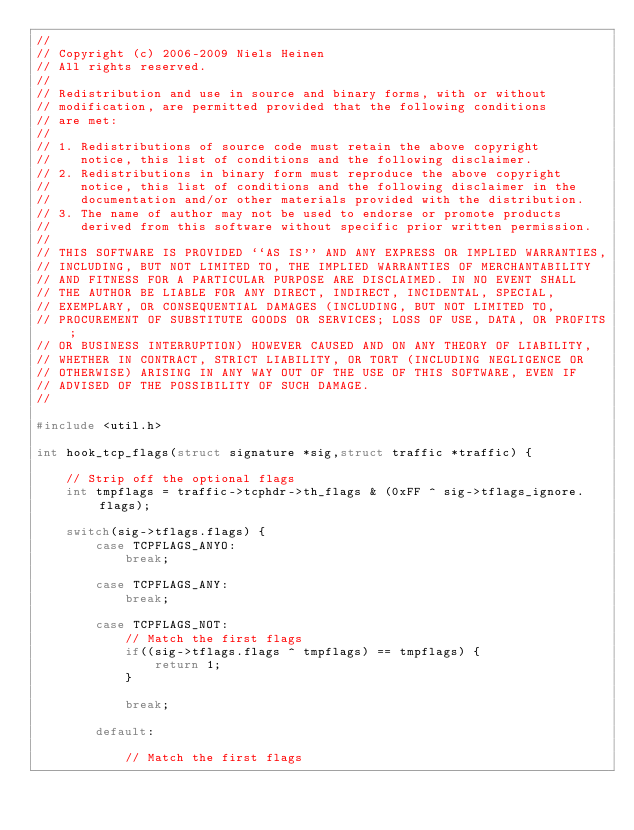Convert code to text. <code><loc_0><loc_0><loc_500><loc_500><_C_>//
// Copyright (c) 2006-2009 Niels Heinen
// All rights reserved.
//
// Redistribution and use in source and binary forms, with or without
// modification, are permitted provided that the following conditions
// are met:
//
// 1. Redistributions of source code must retain the above copyright
//    notice, this list of conditions and the following disclaimer.
// 2. Redistributions in binary form must reproduce the above copyright
//    notice, this list of conditions and the following disclaimer in the
//    documentation and/or other materials provided with the distribution.
// 3. The name of author may not be used to endorse or promote products
//    derived from this software without specific prior written permission.
//
// THIS SOFTWARE IS PROVIDED ``AS IS'' AND ANY EXPRESS OR IMPLIED WARRANTIES,
// INCLUDING, BUT NOT LIMITED TO, THE IMPLIED WARRANTIES OF MERCHANTABILITY
// AND FITNESS FOR A PARTICULAR PURPOSE ARE DISCLAIMED. IN NO EVENT SHALL
// THE AUTHOR BE LIABLE FOR ANY DIRECT, INDIRECT, INCIDENTAL, SPECIAL,
// EXEMPLARY, OR CONSEQUENTIAL DAMAGES (INCLUDING, BUT NOT LIMITED TO,
// PROCUREMENT OF SUBSTITUTE GOODS OR SERVICES; LOSS OF USE, DATA, OR PROFITS;
// OR BUSINESS INTERRUPTION) HOWEVER CAUSED AND ON ANY THEORY OF LIABILITY,
// WHETHER IN CONTRACT, STRICT LIABILITY, OR TORT (INCLUDING NEGLIGENCE OR
// OTHERWISE) ARISING IN ANY WAY OUT OF THE USE OF THIS SOFTWARE, EVEN IF
// ADVISED OF THE POSSIBILITY OF SUCH DAMAGE.
//

#include <util.h>

int hook_tcp_flags(struct signature *sig,struct traffic *traffic) {
	
	// Strip off the optional flags 
	int tmpflags = traffic->tcphdr->th_flags & (0xFF ^ sig->tflags_ignore.flags);

	switch(sig->tflags.flags) {
		case TCPFLAGS_ANYO:
			break;

		case TCPFLAGS_ANY:
			break;

		case TCPFLAGS_NOT:
			// Match the first flags
			if((sig->tflags.flags ^ tmpflags) == tmpflags) {
				return 1;
			}	

			break;

		default:
		
			// Match the first flags</code> 